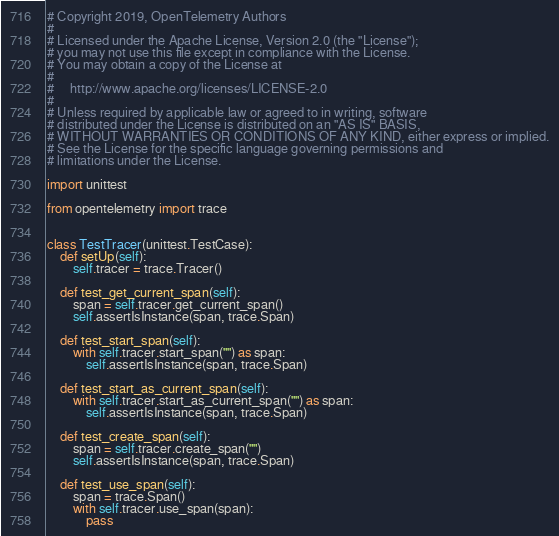Convert code to text. <code><loc_0><loc_0><loc_500><loc_500><_Python_># Copyright 2019, OpenTelemetry Authors
#
# Licensed under the Apache License, Version 2.0 (the "License");
# you may not use this file except in compliance with the License.
# You may obtain a copy of the License at
#
#     http://www.apache.org/licenses/LICENSE-2.0
#
# Unless required by applicable law or agreed to in writing, software
# distributed under the License is distributed on an "AS IS" BASIS,
# WITHOUT WARRANTIES OR CONDITIONS OF ANY KIND, either express or implied.
# See the License for the specific language governing permissions and
# limitations under the License.

import unittest

from opentelemetry import trace


class TestTracer(unittest.TestCase):
    def setUp(self):
        self.tracer = trace.Tracer()

    def test_get_current_span(self):
        span = self.tracer.get_current_span()
        self.assertIsInstance(span, trace.Span)

    def test_start_span(self):
        with self.tracer.start_span("") as span:
            self.assertIsInstance(span, trace.Span)

    def test_start_as_current_span(self):
        with self.tracer.start_as_current_span("") as span:
            self.assertIsInstance(span, trace.Span)

    def test_create_span(self):
        span = self.tracer.create_span("")
        self.assertIsInstance(span, trace.Span)

    def test_use_span(self):
        span = trace.Span()
        with self.tracer.use_span(span):
            pass
</code> 